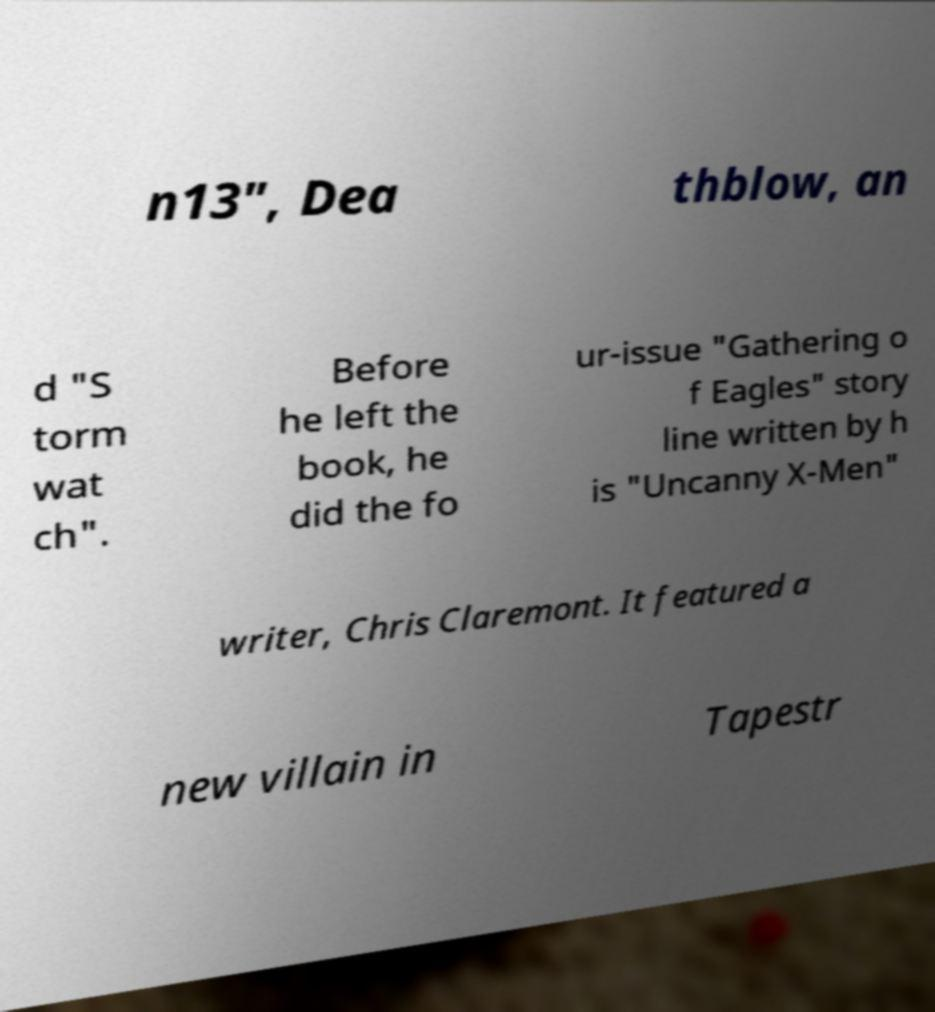Can you accurately transcribe the text from the provided image for me? n13", Dea thblow, an d "S torm wat ch". Before he left the book, he did the fo ur-issue "Gathering o f Eagles" story line written by h is "Uncanny X-Men" writer, Chris Claremont. It featured a new villain in Tapestr 